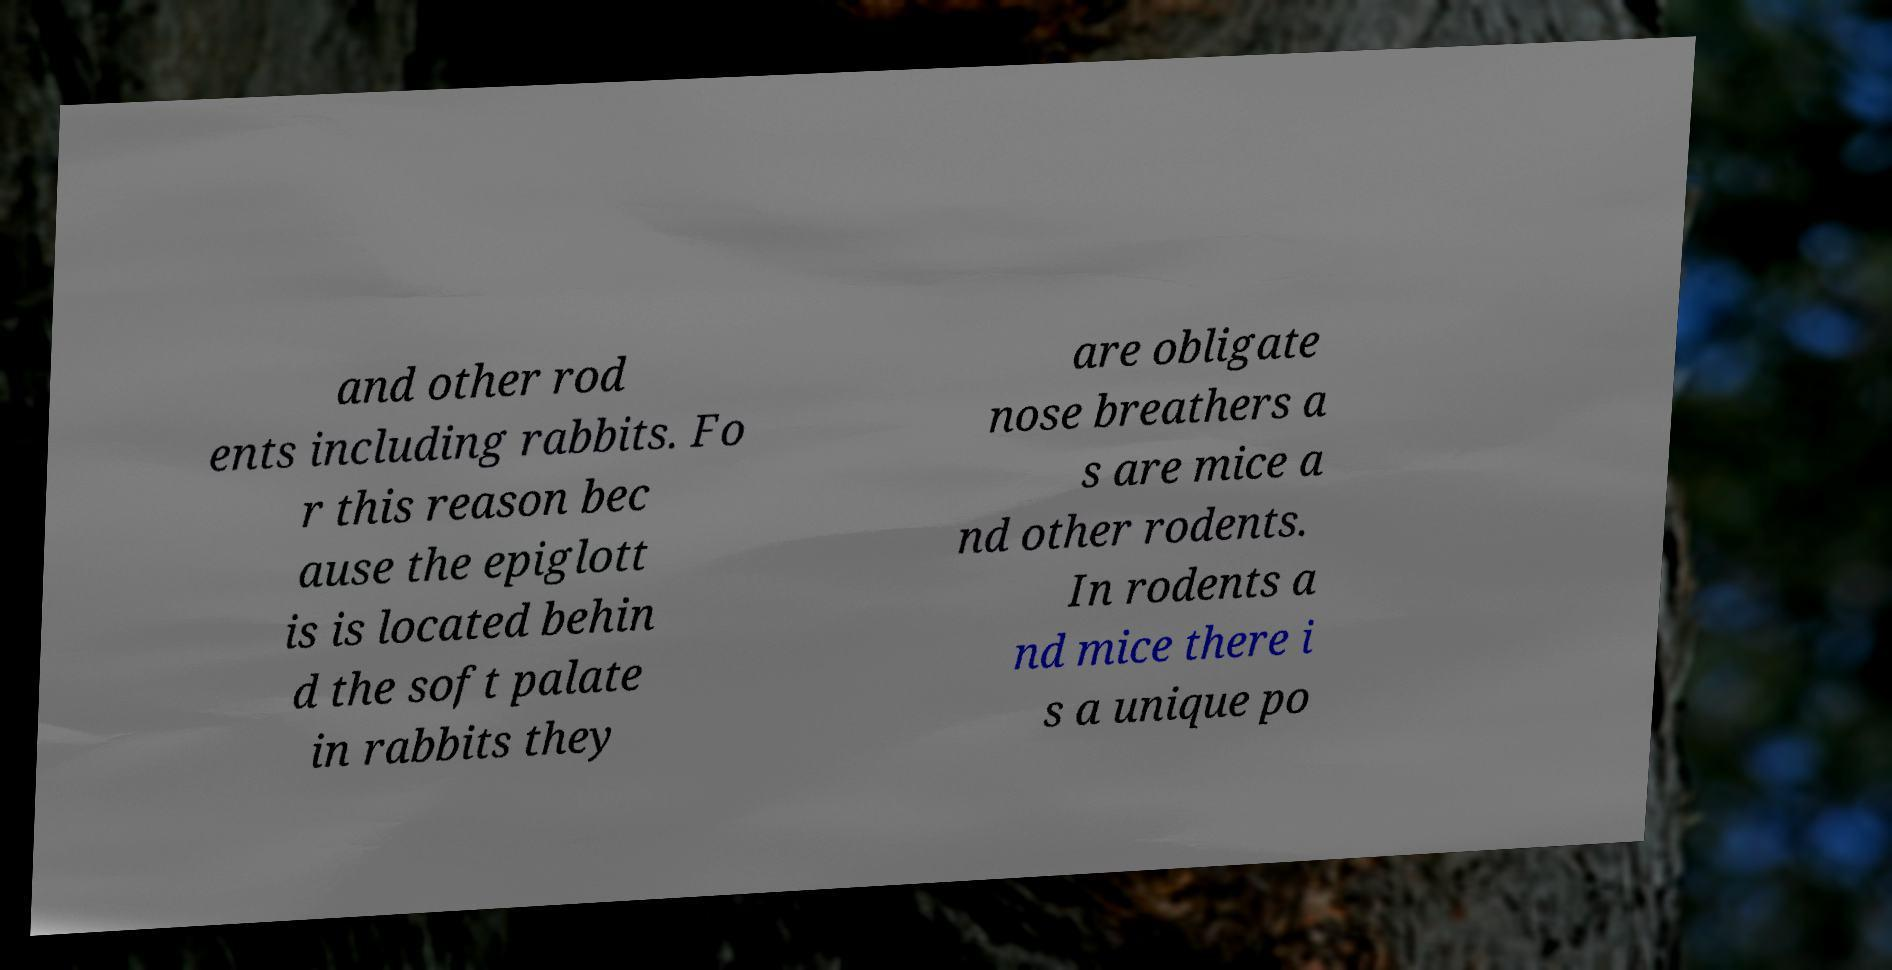Could you extract and type out the text from this image? and other rod ents including rabbits. Fo r this reason bec ause the epiglott is is located behin d the soft palate in rabbits they are obligate nose breathers a s are mice a nd other rodents. In rodents a nd mice there i s a unique po 